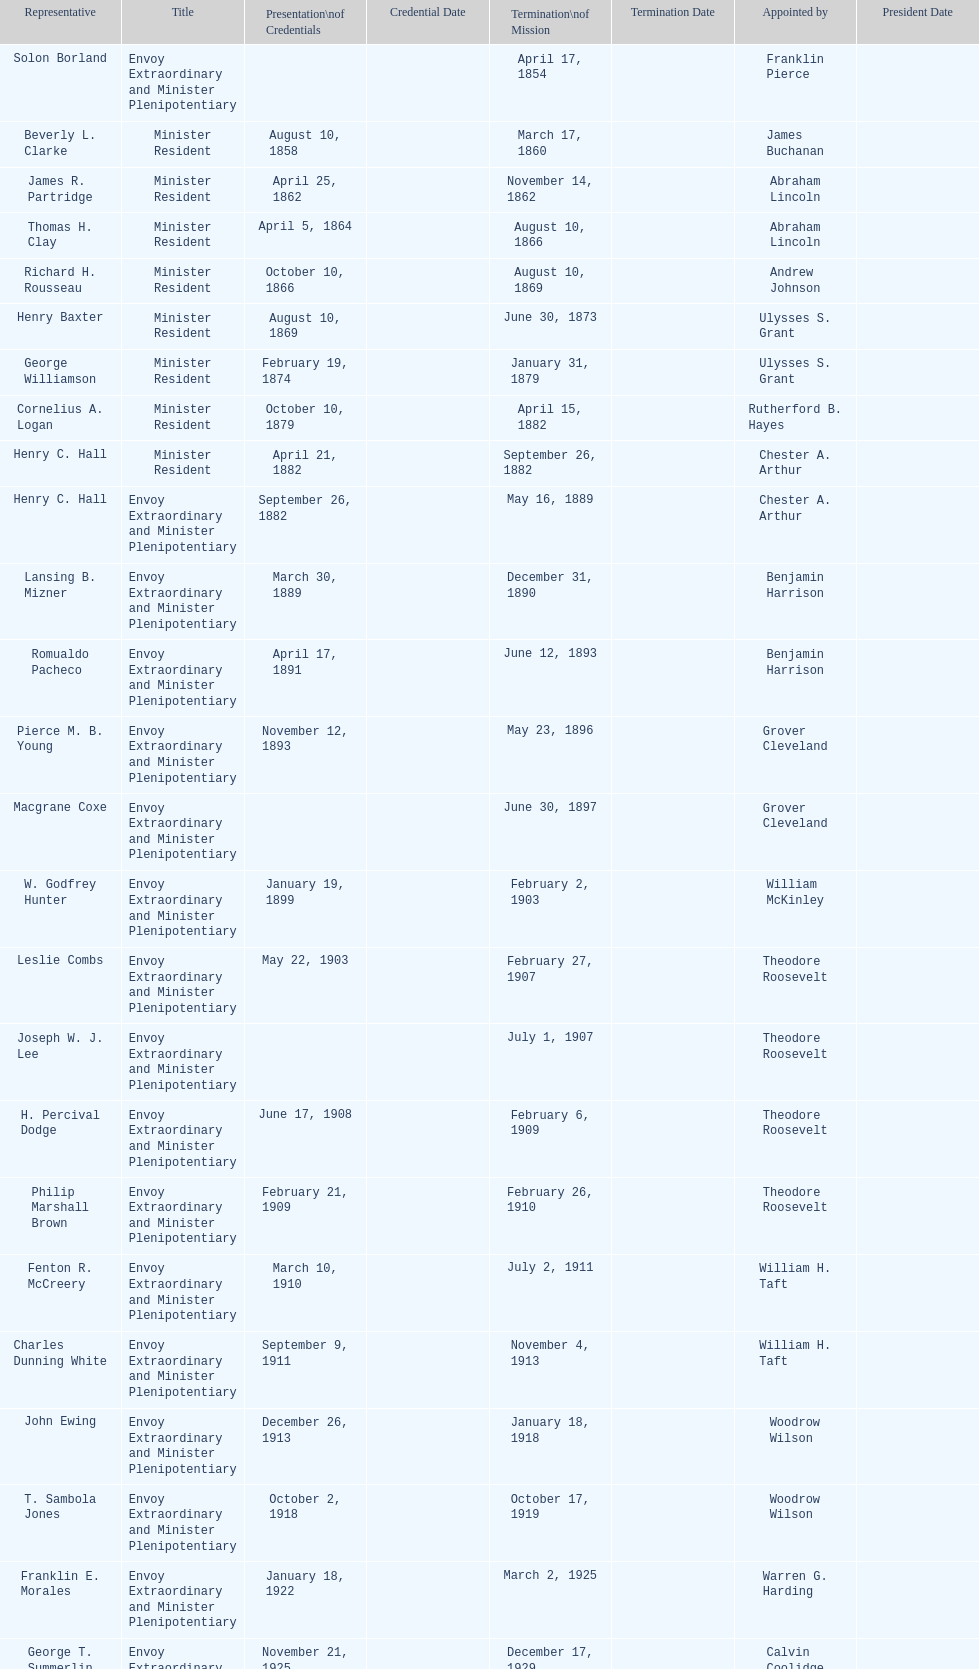How many total representatives have there been? 50. 